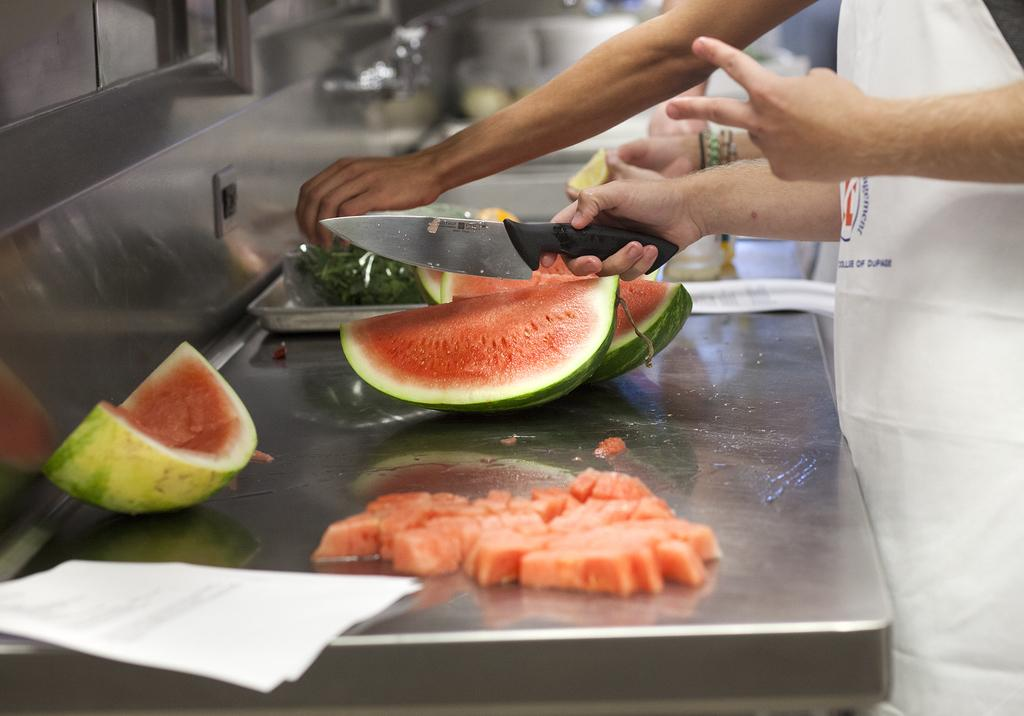What body parts are visible in the image? There are persons' hands visible in the image. What type of food can be seen in the image? There are watermelon pieces in the image. On what surface are the watermelon pieces placed? The watermelon pieces are on a thing (possibly a plate or cutting board) in the image. What is the white object in the image? There is a white paper in the image. What utensil is being used in the image? A person is holding a knife in their hand. What type of picture is hanging on the wall in the image? There is no picture hanging on the wall in the image; the focus is on the hands, watermelon pieces, and the knife. How many tomatoes are visible in the image? There are no tomatoes present in the image. 